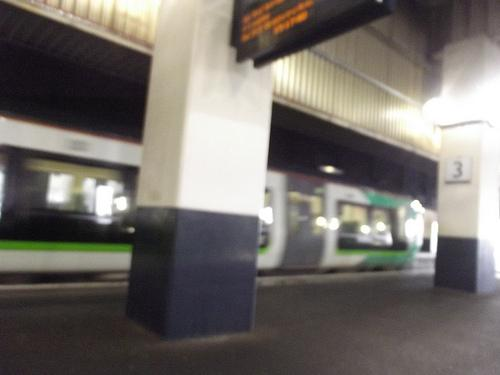What is the color of the sign hanging on the post? The sign hanging on the post has orange letters on a black background. Mention the colors of the stripe on the train. There is a green stripe on the train. What is the color of the platform in the image? The platform's cement waiting area is grey in color. Specify what the number displayed on the column sign is. The number displayed on the column sign is 3. Describe the appearance of the windows on the train. The windows on the train have a black border and are reflecting light. Identify the primary color of the train in the image. The train is primarily white with green and grey accents. Describe the state of the train in terms of focus and clarity. The train appears blurry and not focused in the image. What type of display is seen in the image? An electronic informational display is seen in the image. Explain the current situation of the train in the image. The train is passing by, and it is in motion with its doors shut. Point out the colors of the pillar(s) seen in the image. The colors of the pillars are white, grey, and black. Can you point out the purple suitcase on the platform next to the train? A purple suitcase is not mentioned in any of the existing captions and seems irrelevant to the scene. Where is the sleeping dog on the train platform? No, it's not mentioned in the image. The train conductor is waving from behind the window of the leading car. There is no mention of a train conductor or anyone waving in the provided information. A large, colorful advertisement is displayed on the side of the train. There is no mention of any advertisement on the train's exterior. Can you find the orange construction cone on the train platform? There is no mention of a construction cone or any related object on the platform. The man wearing a hat is standing beside the white and green train. There is no mention of any person in the image, let alone someone wearing a hat. 